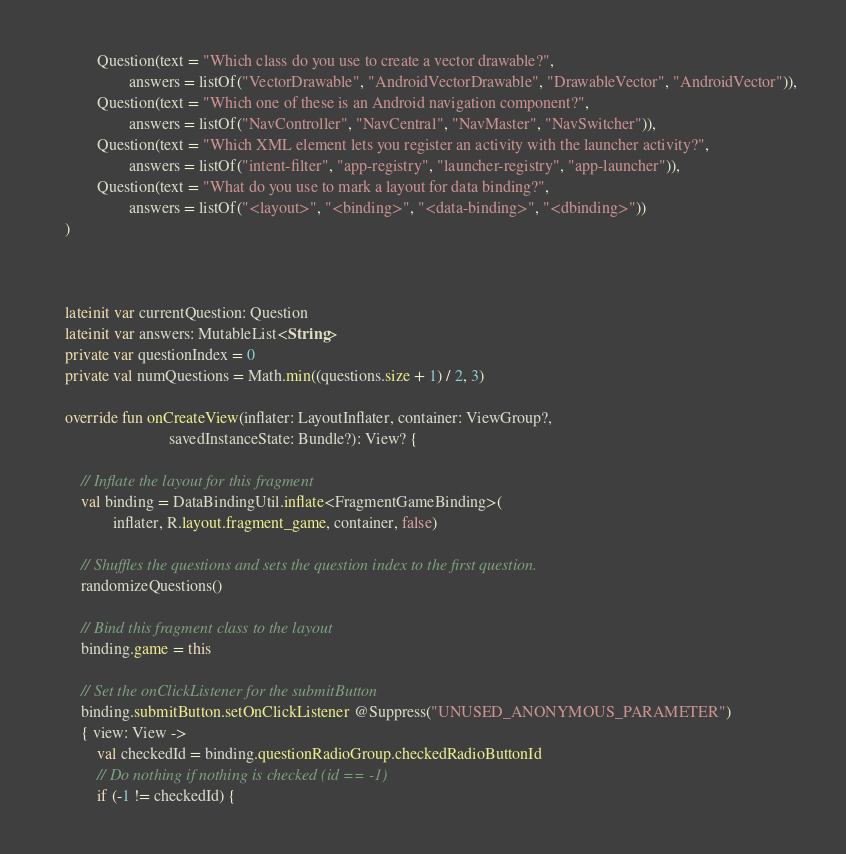Convert code to text. <code><loc_0><loc_0><loc_500><loc_500><_Kotlin_>            Question(text = "Which class do you use to create a vector drawable?",
                    answers = listOf("VectorDrawable", "AndroidVectorDrawable", "DrawableVector", "AndroidVector")),
            Question(text = "Which one of these is an Android navigation component?",
                    answers = listOf("NavController", "NavCentral", "NavMaster", "NavSwitcher")),
            Question(text = "Which XML element lets you register an activity with the launcher activity?",
                    answers = listOf("intent-filter", "app-registry", "launcher-registry", "app-launcher")),
            Question(text = "What do you use to mark a layout for data binding?",
                    answers = listOf("<layout>", "<binding>", "<data-binding>", "<dbinding>"))
    )



    lateinit var currentQuestion: Question
    lateinit var answers: MutableList<String>
    private var questionIndex = 0
    private val numQuestions = Math.min((questions.size + 1) / 2, 3)

    override fun onCreateView(inflater: LayoutInflater, container: ViewGroup?,
                              savedInstanceState: Bundle?): View? {

        // Inflate the layout for this fragment
        val binding = DataBindingUtil.inflate<FragmentGameBinding>(
                inflater, R.layout.fragment_game, container, false)

        // Shuffles the questions and sets the question index to the first question.
        randomizeQuestions()

        // Bind this fragment class to the layout
        binding.game = this

        // Set the onClickListener for the submitButton
        binding.submitButton.setOnClickListener @Suppress("UNUSED_ANONYMOUS_PARAMETER")
        { view: View ->
            val checkedId = binding.questionRadioGroup.checkedRadioButtonId
            // Do nothing if nothing is checked (id == -1)
            if (-1 != checkedId) {</code> 